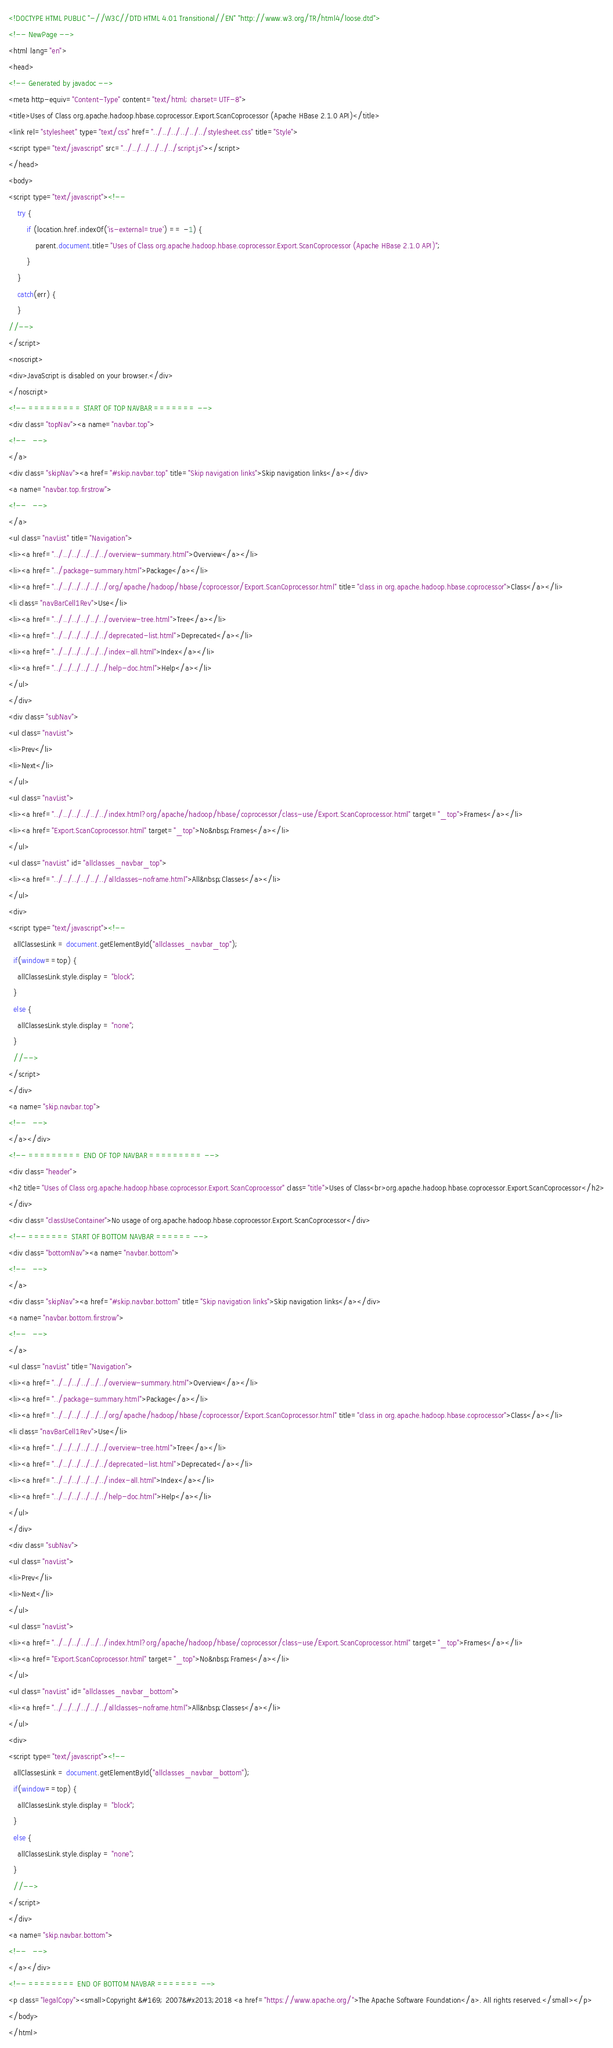<code> <loc_0><loc_0><loc_500><loc_500><_HTML_><!DOCTYPE HTML PUBLIC "-//W3C//DTD HTML 4.01 Transitional//EN" "http://www.w3.org/TR/html4/loose.dtd">
<!-- NewPage -->
<html lang="en">
<head>
<!-- Generated by javadoc -->
<meta http-equiv="Content-Type" content="text/html; charset=UTF-8">
<title>Uses of Class org.apache.hadoop.hbase.coprocessor.Export.ScanCoprocessor (Apache HBase 2.1.0 API)</title>
<link rel="stylesheet" type="text/css" href="../../../../../../stylesheet.css" title="Style">
<script type="text/javascript" src="../../../../../../script.js"></script>
</head>
<body>
<script type="text/javascript"><!--
    try {
        if (location.href.indexOf('is-external=true') == -1) {
            parent.document.title="Uses of Class org.apache.hadoop.hbase.coprocessor.Export.ScanCoprocessor (Apache HBase 2.1.0 API)";
        }
    }
    catch(err) {
    }
//-->
</script>
<noscript>
<div>JavaScript is disabled on your browser.</div>
</noscript>
<!-- ========= START OF TOP NAVBAR ======= -->
<div class="topNav"><a name="navbar.top">
<!--   -->
</a>
<div class="skipNav"><a href="#skip.navbar.top" title="Skip navigation links">Skip navigation links</a></div>
<a name="navbar.top.firstrow">
<!--   -->
</a>
<ul class="navList" title="Navigation">
<li><a href="../../../../../../overview-summary.html">Overview</a></li>
<li><a href="../package-summary.html">Package</a></li>
<li><a href="../../../../../../org/apache/hadoop/hbase/coprocessor/Export.ScanCoprocessor.html" title="class in org.apache.hadoop.hbase.coprocessor">Class</a></li>
<li class="navBarCell1Rev">Use</li>
<li><a href="../../../../../../overview-tree.html">Tree</a></li>
<li><a href="../../../../../../deprecated-list.html">Deprecated</a></li>
<li><a href="../../../../../../index-all.html">Index</a></li>
<li><a href="../../../../../../help-doc.html">Help</a></li>
</ul>
</div>
<div class="subNav">
<ul class="navList">
<li>Prev</li>
<li>Next</li>
</ul>
<ul class="navList">
<li><a href="../../../../../../index.html?org/apache/hadoop/hbase/coprocessor/class-use/Export.ScanCoprocessor.html" target="_top">Frames</a></li>
<li><a href="Export.ScanCoprocessor.html" target="_top">No&nbsp;Frames</a></li>
</ul>
<ul class="navList" id="allclasses_navbar_top">
<li><a href="../../../../../../allclasses-noframe.html">All&nbsp;Classes</a></li>
</ul>
<div>
<script type="text/javascript"><!--
  allClassesLink = document.getElementById("allclasses_navbar_top");
  if(window==top) {
    allClassesLink.style.display = "block";
  }
  else {
    allClassesLink.style.display = "none";
  }
  //-->
</script>
</div>
<a name="skip.navbar.top">
<!--   -->
</a></div>
<!-- ========= END OF TOP NAVBAR ========= -->
<div class="header">
<h2 title="Uses of Class org.apache.hadoop.hbase.coprocessor.Export.ScanCoprocessor" class="title">Uses of Class<br>org.apache.hadoop.hbase.coprocessor.Export.ScanCoprocessor</h2>
</div>
<div class="classUseContainer">No usage of org.apache.hadoop.hbase.coprocessor.Export.ScanCoprocessor</div>
<!-- ======= START OF BOTTOM NAVBAR ====== -->
<div class="bottomNav"><a name="navbar.bottom">
<!--   -->
</a>
<div class="skipNav"><a href="#skip.navbar.bottom" title="Skip navigation links">Skip navigation links</a></div>
<a name="navbar.bottom.firstrow">
<!--   -->
</a>
<ul class="navList" title="Navigation">
<li><a href="../../../../../../overview-summary.html">Overview</a></li>
<li><a href="../package-summary.html">Package</a></li>
<li><a href="../../../../../../org/apache/hadoop/hbase/coprocessor/Export.ScanCoprocessor.html" title="class in org.apache.hadoop.hbase.coprocessor">Class</a></li>
<li class="navBarCell1Rev">Use</li>
<li><a href="../../../../../../overview-tree.html">Tree</a></li>
<li><a href="../../../../../../deprecated-list.html">Deprecated</a></li>
<li><a href="../../../../../../index-all.html">Index</a></li>
<li><a href="../../../../../../help-doc.html">Help</a></li>
</ul>
</div>
<div class="subNav">
<ul class="navList">
<li>Prev</li>
<li>Next</li>
</ul>
<ul class="navList">
<li><a href="../../../../../../index.html?org/apache/hadoop/hbase/coprocessor/class-use/Export.ScanCoprocessor.html" target="_top">Frames</a></li>
<li><a href="Export.ScanCoprocessor.html" target="_top">No&nbsp;Frames</a></li>
</ul>
<ul class="navList" id="allclasses_navbar_bottom">
<li><a href="../../../../../../allclasses-noframe.html">All&nbsp;Classes</a></li>
</ul>
<div>
<script type="text/javascript"><!--
  allClassesLink = document.getElementById("allclasses_navbar_bottom");
  if(window==top) {
    allClassesLink.style.display = "block";
  }
  else {
    allClassesLink.style.display = "none";
  }
  //-->
</script>
</div>
<a name="skip.navbar.bottom">
<!--   -->
</a></div>
<!-- ======== END OF BOTTOM NAVBAR ======= -->
<p class="legalCopy"><small>Copyright &#169; 2007&#x2013;2018 <a href="https://www.apache.org/">The Apache Software Foundation</a>. All rights reserved.</small></p>
</body>
</html>
</code> 